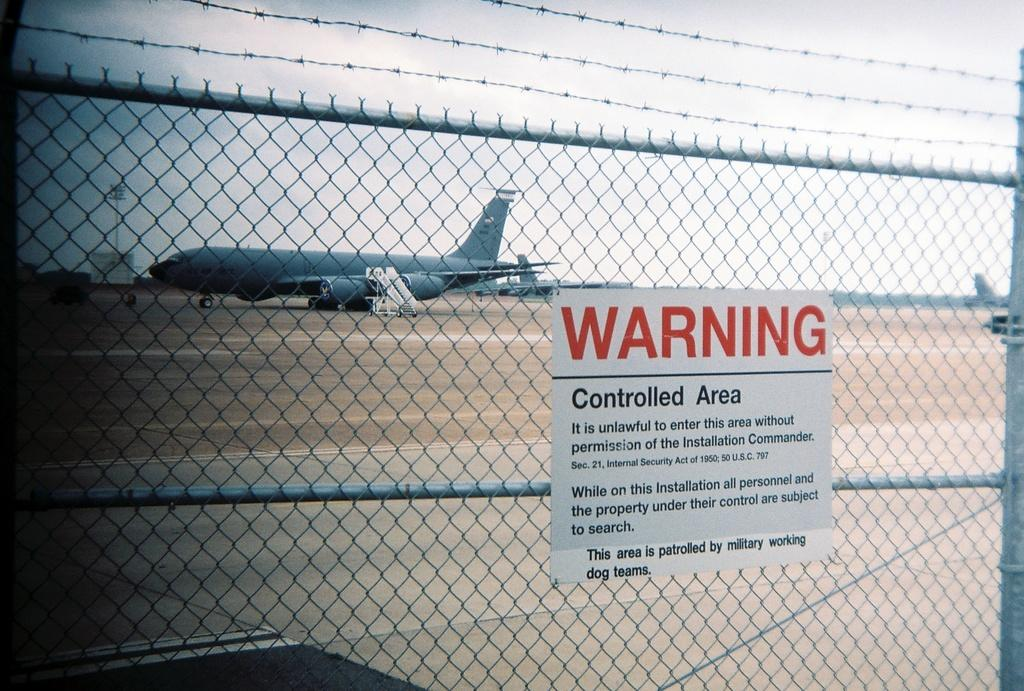<image>
Create a compact narrative representing the image presented. A Warning sign for Controlled Area hangs on a fence in front of an airplane on a tarmac 